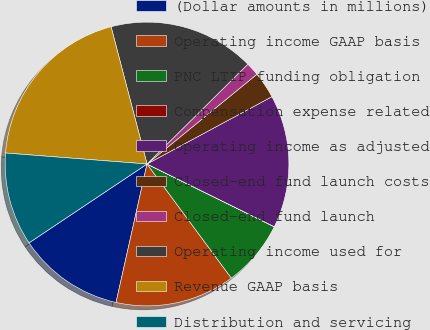<chart> <loc_0><loc_0><loc_500><loc_500><pie_chart><fcel>(Dollar amounts in millions)<fcel>Operating income GAAP basis<fcel>PNC LTIP funding obligation<fcel>Compensation expense related<fcel>Operating income as adjusted<fcel>Closed-end fund launch costs<fcel>Closed-end fund launch<fcel>Operating income used for<fcel>Revenue GAAP basis<fcel>Distribution and servicing<nl><fcel>12.12%<fcel>13.63%<fcel>7.58%<fcel>0.01%<fcel>15.15%<fcel>3.03%<fcel>1.52%<fcel>16.66%<fcel>19.69%<fcel>10.61%<nl></chart> 